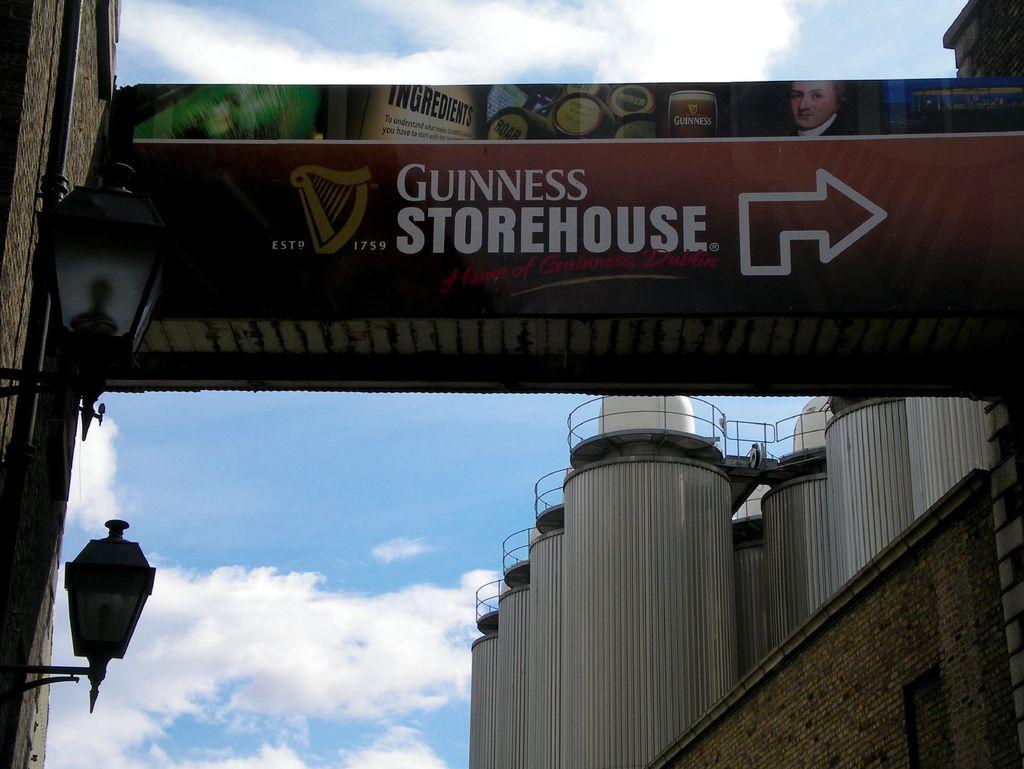What year where they established?
Ensure brevity in your answer.  1759. 